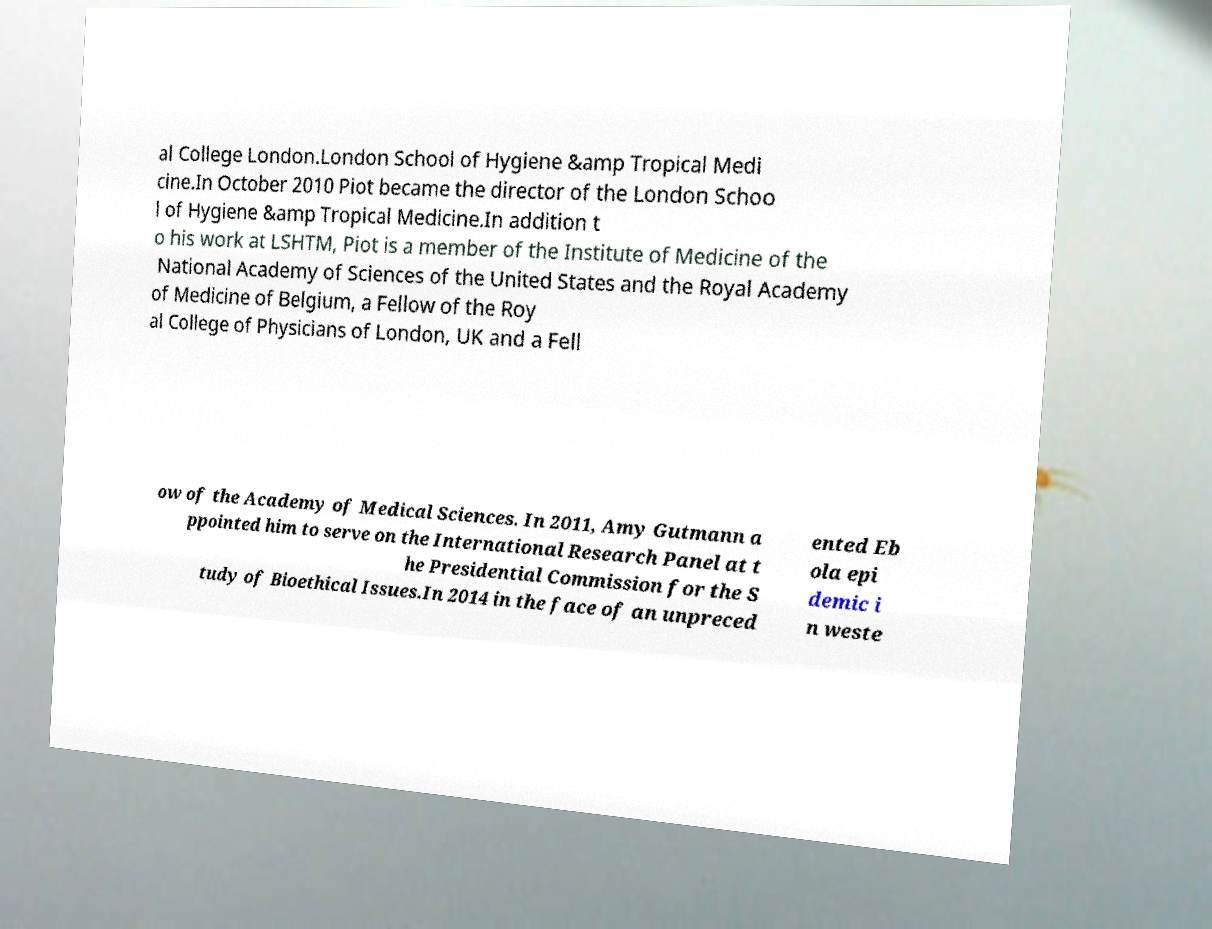Can you accurately transcribe the text from the provided image for me? al College London.London School of Hygiene &amp Tropical Medi cine.In October 2010 Piot became the director of the London Schoo l of Hygiene &amp Tropical Medicine.In addition t o his work at LSHTM, Piot is a member of the Institute of Medicine of the National Academy of Sciences of the United States and the Royal Academy of Medicine of Belgium, a Fellow of the Roy al College of Physicians of London, UK and a Fell ow of the Academy of Medical Sciences. In 2011, Amy Gutmann a ppointed him to serve on the International Research Panel at t he Presidential Commission for the S tudy of Bioethical Issues.In 2014 in the face of an unpreced ented Eb ola epi demic i n weste 